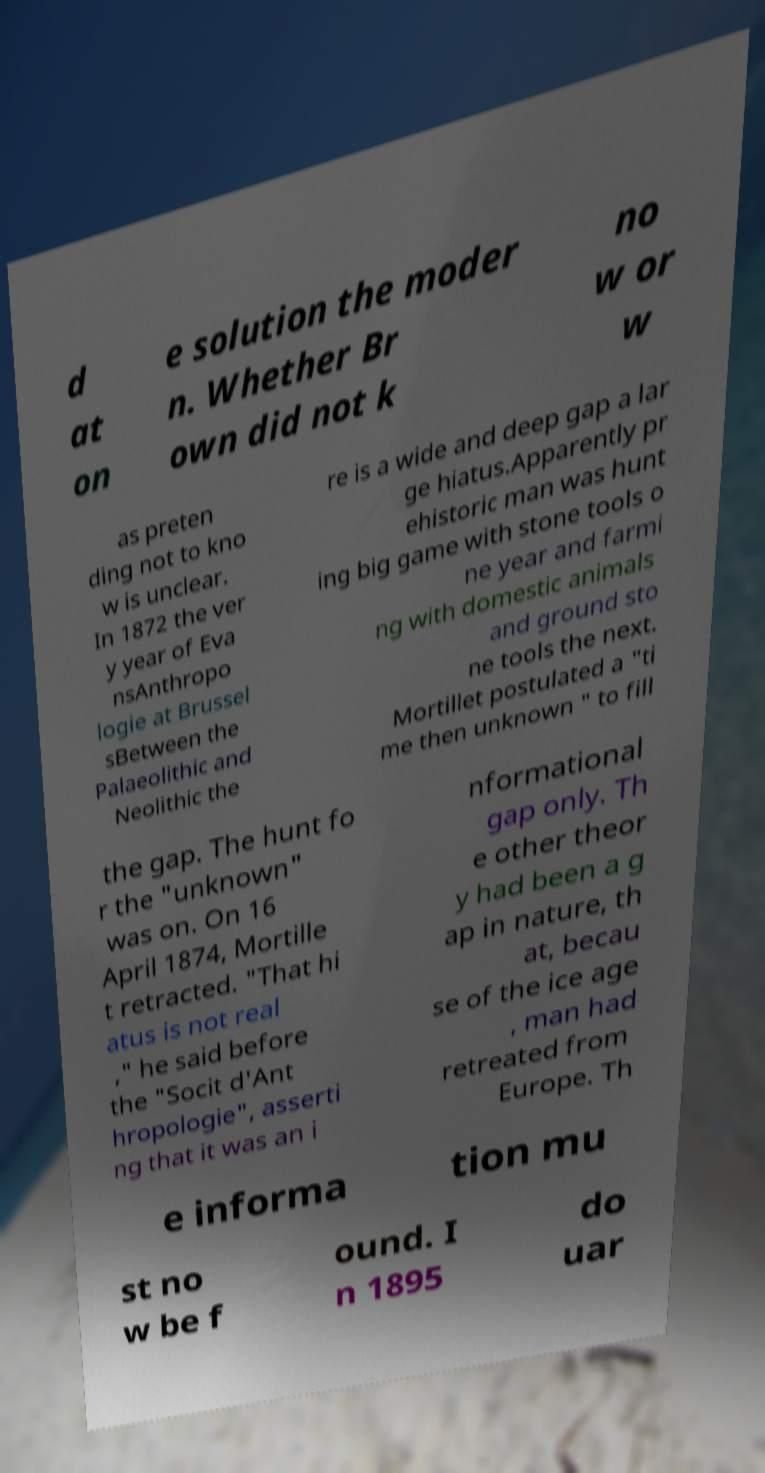For documentation purposes, I need the text within this image transcribed. Could you provide that? d at on e solution the moder n. Whether Br own did not k no w or w as preten ding not to kno w is unclear. In 1872 the ver y year of Eva nsAnthropo logie at Brussel sBetween the Palaeolithic and Neolithic the re is a wide and deep gap a lar ge hiatus.Apparently pr ehistoric man was hunt ing big game with stone tools o ne year and farmi ng with domestic animals and ground sto ne tools the next. Mortillet postulated a "ti me then unknown " to fill the gap. The hunt fo r the "unknown" was on. On 16 April 1874, Mortille t retracted. "That hi atus is not real ," he said before the "Socit d'Ant hropologie", asserti ng that it was an i nformational gap only. Th e other theor y had been a g ap in nature, th at, becau se of the ice age , man had retreated from Europe. Th e informa tion mu st no w be f ound. I n 1895 do uar 